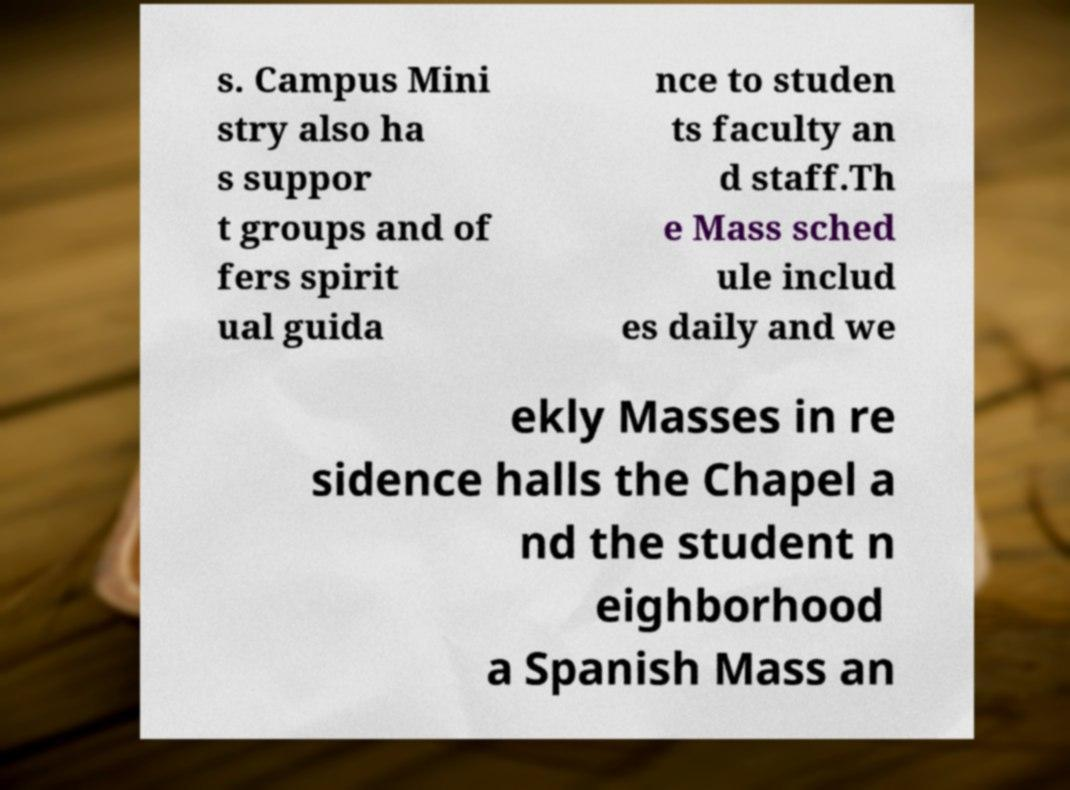Please identify and transcribe the text found in this image. s. Campus Mini stry also ha s suppor t groups and of fers spirit ual guida nce to studen ts faculty an d staff.Th e Mass sched ule includ es daily and we ekly Masses in re sidence halls the Chapel a nd the student n eighborhood a Spanish Mass an 